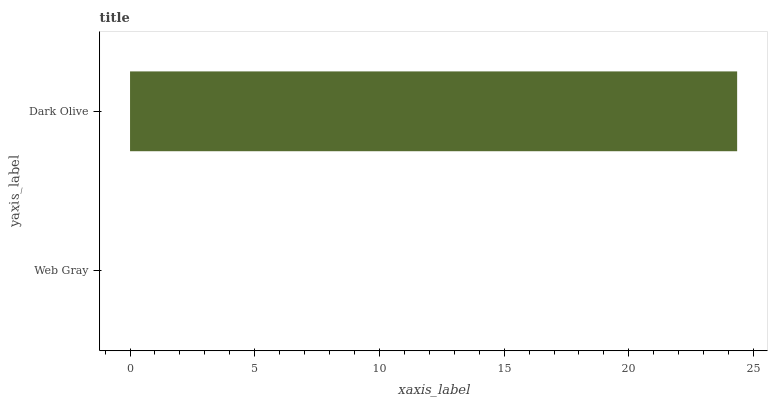Is Web Gray the minimum?
Answer yes or no. Yes. Is Dark Olive the maximum?
Answer yes or no. Yes. Is Dark Olive the minimum?
Answer yes or no. No. Is Dark Olive greater than Web Gray?
Answer yes or no. Yes. Is Web Gray less than Dark Olive?
Answer yes or no. Yes. Is Web Gray greater than Dark Olive?
Answer yes or no. No. Is Dark Olive less than Web Gray?
Answer yes or no. No. Is Dark Olive the high median?
Answer yes or no. Yes. Is Web Gray the low median?
Answer yes or no. Yes. Is Web Gray the high median?
Answer yes or no. No. Is Dark Olive the low median?
Answer yes or no. No. 